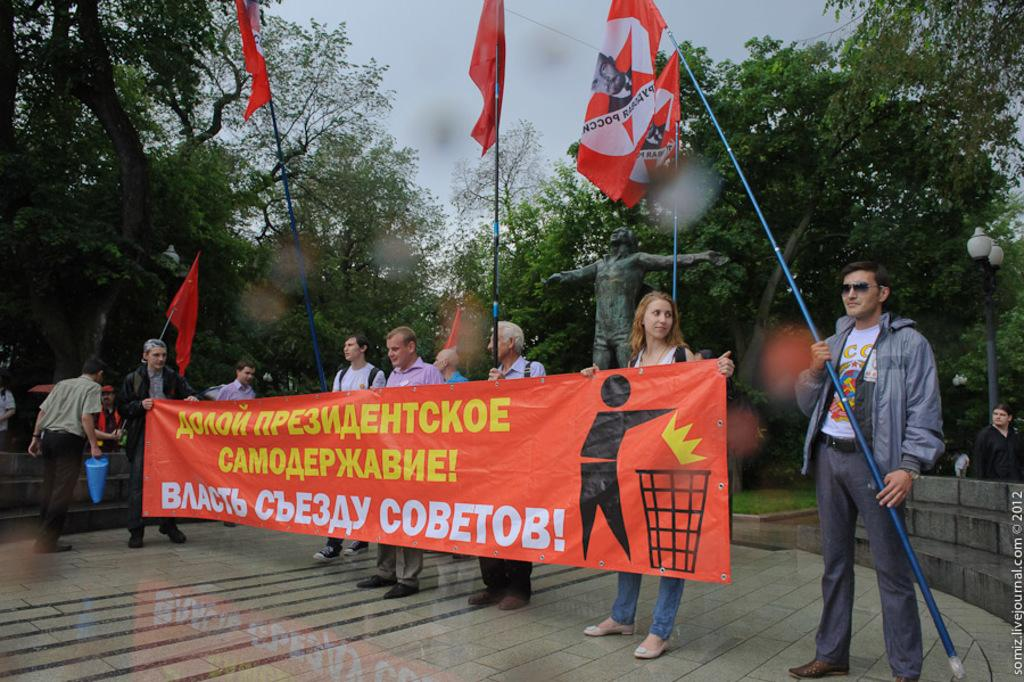What are the people in the foreground of the image holding? The people in the foreground of the image are holding a poster. What else can be seen in the foreground of the image? There are flags in the foreground of the image. What architectural feature is visible in the background of the image? There are stairs in the background of the image. What other elements can be seen in the background of the image? There are people, a pole, a statue, trees, and the sky visible in the background of the image. How many hands are visible on the statue in the image? There is no mention of hands on the statue in the image, and the statue is not described in detail. Are the people in the background of the image brothers? There is no information provided about the relationship between the people in the background of the image, so we cannot determine if they are brothers. 